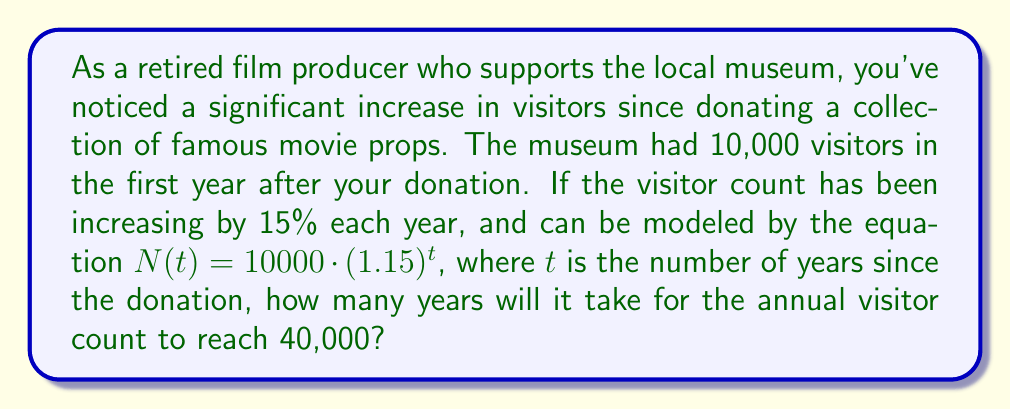What is the answer to this math problem? Let's approach this step-by-step using logarithms:

1) We're given the exponential growth model:
   $N(t) = 10000 \cdot (1.15)^t$

2) We want to find $t$ when $N(t) = 40000$. So, let's set up the equation:
   $40000 = 10000 \cdot (1.15)^t$

3) Divide both sides by 10000:
   $4 = (1.15)^t$

4) Now, we can apply logarithms to both sides. Let's use natural log (ln):
   $\ln(4) = \ln((1.15)^t)$

5) Using the logarithm property $\ln(a^b) = b\ln(a)$, we get:
   $\ln(4) = t \cdot \ln(1.15)$

6) Now we can solve for $t$:
   $t = \frac{\ln(4)}{\ln(1.15)}$

7) Using a calculator:
   $t \approx 9.98$ years

8) Since we're dealing with whole years, we round up to the nearest integer.
Answer: It will take 10 years for the annual visitor count to reach 40,000. 